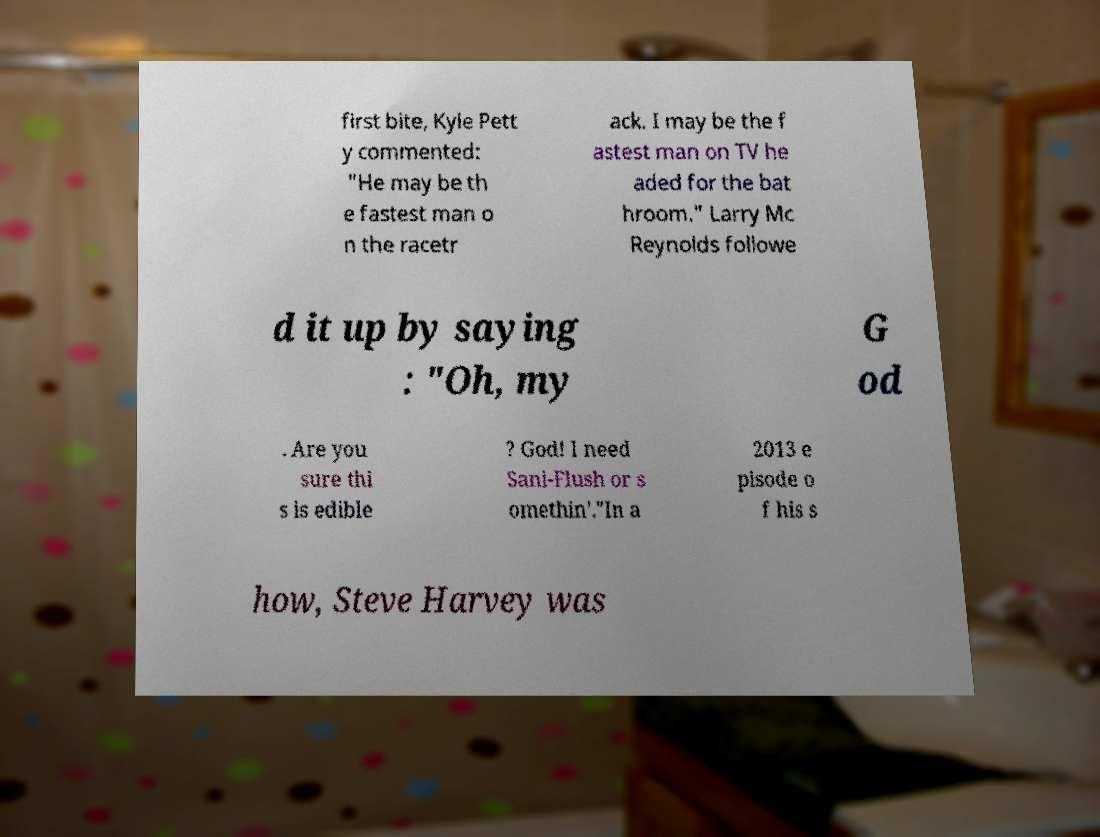Could you extract and type out the text from this image? first bite, Kyle Pett y commented: "He may be th e fastest man o n the racetr ack. I may be the f astest man on TV he aded for the bat hroom." Larry Mc Reynolds followe d it up by saying : "Oh, my G od . Are you sure thi s is edible ? God! I need Sani-Flush or s omethin'."In a 2013 e pisode o f his s how, Steve Harvey was 